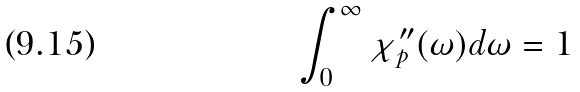<formula> <loc_0><loc_0><loc_500><loc_500>\int _ { 0 } ^ { \infty } \chi _ { p } ^ { \prime \prime } ( \omega ) d \omega = 1</formula> 